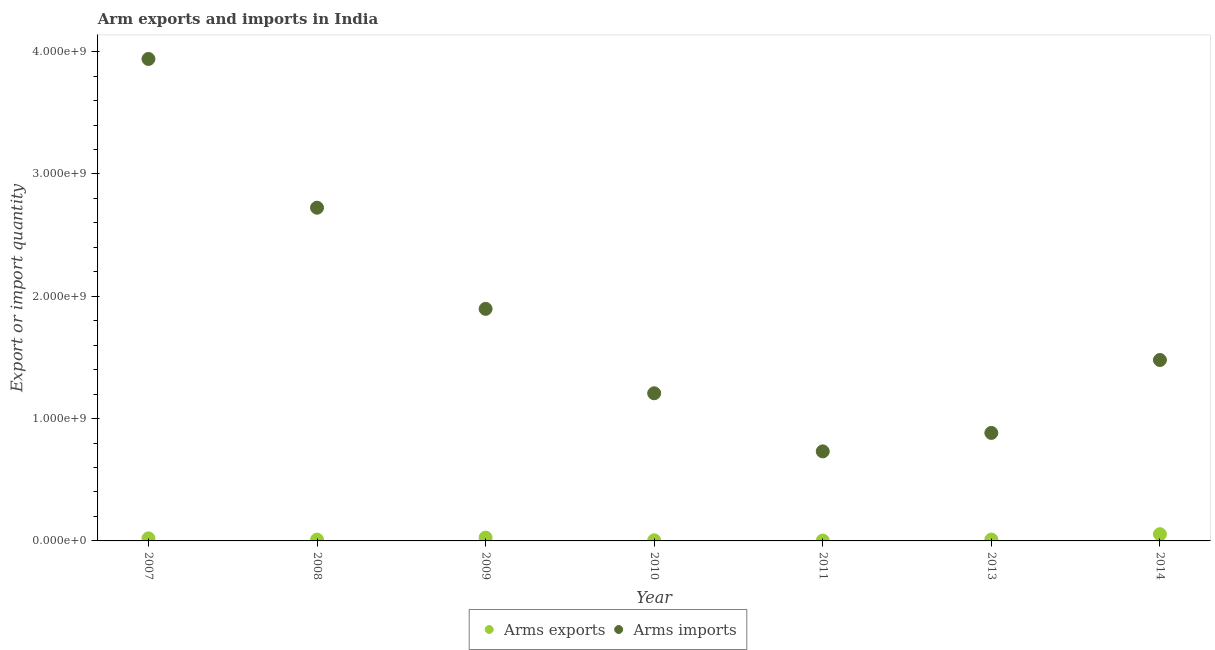What is the arms exports in 2007?
Offer a terse response. 2.10e+07. Across all years, what is the maximum arms exports?
Keep it short and to the point. 5.50e+07. Across all years, what is the minimum arms exports?
Your answer should be very brief. 3.00e+06. In which year was the arms exports maximum?
Make the answer very short. 2014. What is the total arms imports in the graph?
Make the answer very short. 1.29e+1. What is the difference between the arms imports in 2007 and that in 2013?
Offer a very short reply. 3.06e+09. What is the difference between the arms imports in 2011 and the arms exports in 2009?
Offer a terse response. 7.05e+08. What is the average arms imports per year?
Ensure brevity in your answer.  1.84e+09. In the year 2009, what is the difference between the arms exports and arms imports?
Your answer should be very brief. -1.87e+09. Is the arms imports in 2008 less than that in 2010?
Give a very brief answer. No. Is the difference between the arms exports in 2007 and 2010 greater than the difference between the arms imports in 2007 and 2010?
Offer a terse response. No. What is the difference between the highest and the second highest arms imports?
Provide a succinct answer. 1.22e+09. What is the difference between the highest and the lowest arms imports?
Provide a succinct answer. 3.21e+09. Is the sum of the arms exports in 2007 and 2010 greater than the maximum arms imports across all years?
Offer a terse response. No. Does the arms imports monotonically increase over the years?
Offer a terse response. No. How many dotlines are there?
Your response must be concise. 2. How many years are there in the graph?
Make the answer very short. 7. Are the values on the major ticks of Y-axis written in scientific E-notation?
Give a very brief answer. Yes. How many legend labels are there?
Your answer should be compact. 2. How are the legend labels stacked?
Ensure brevity in your answer.  Horizontal. What is the title of the graph?
Provide a short and direct response. Arm exports and imports in India. Does "Rural Population" appear as one of the legend labels in the graph?
Ensure brevity in your answer.  No. What is the label or title of the Y-axis?
Your answer should be very brief. Export or import quantity. What is the Export or import quantity in Arms exports in 2007?
Provide a succinct answer. 2.10e+07. What is the Export or import quantity in Arms imports in 2007?
Give a very brief answer. 3.94e+09. What is the Export or import quantity in Arms exports in 2008?
Your answer should be very brief. 1.10e+07. What is the Export or import quantity of Arms imports in 2008?
Offer a terse response. 2.72e+09. What is the Export or import quantity in Arms exports in 2009?
Your answer should be compact. 2.70e+07. What is the Export or import quantity in Arms imports in 2009?
Your response must be concise. 1.90e+09. What is the Export or import quantity in Arms exports in 2010?
Make the answer very short. 5.00e+06. What is the Export or import quantity of Arms imports in 2010?
Offer a very short reply. 1.21e+09. What is the Export or import quantity in Arms exports in 2011?
Ensure brevity in your answer.  3.00e+06. What is the Export or import quantity of Arms imports in 2011?
Keep it short and to the point. 7.32e+08. What is the Export or import quantity of Arms exports in 2013?
Your answer should be compact. 1.10e+07. What is the Export or import quantity of Arms imports in 2013?
Your response must be concise. 8.83e+08. What is the Export or import quantity in Arms exports in 2014?
Ensure brevity in your answer.  5.50e+07. What is the Export or import quantity of Arms imports in 2014?
Offer a very short reply. 1.48e+09. Across all years, what is the maximum Export or import quantity of Arms exports?
Make the answer very short. 5.50e+07. Across all years, what is the maximum Export or import quantity of Arms imports?
Provide a succinct answer. 3.94e+09. Across all years, what is the minimum Export or import quantity in Arms imports?
Your answer should be compact. 7.32e+08. What is the total Export or import quantity of Arms exports in the graph?
Make the answer very short. 1.33e+08. What is the total Export or import quantity in Arms imports in the graph?
Your response must be concise. 1.29e+1. What is the difference between the Export or import quantity in Arms imports in 2007 and that in 2008?
Provide a short and direct response. 1.22e+09. What is the difference between the Export or import quantity of Arms exports in 2007 and that in 2009?
Offer a terse response. -6.00e+06. What is the difference between the Export or import quantity in Arms imports in 2007 and that in 2009?
Your response must be concise. 2.04e+09. What is the difference between the Export or import quantity in Arms exports in 2007 and that in 2010?
Give a very brief answer. 1.60e+07. What is the difference between the Export or import quantity in Arms imports in 2007 and that in 2010?
Offer a very short reply. 2.73e+09. What is the difference between the Export or import quantity of Arms exports in 2007 and that in 2011?
Keep it short and to the point. 1.80e+07. What is the difference between the Export or import quantity in Arms imports in 2007 and that in 2011?
Your answer should be very brief. 3.21e+09. What is the difference between the Export or import quantity in Arms imports in 2007 and that in 2013?
Your answer should be compact. 3.06e+09. What is the difference between the Export or import quantity of Arms exports in 2007 and that in 2014?
Make the answer very short. -3.40e+07. What is the difference between the Export or import quantity in Arms imports in 2007 and that in 2014?
Provide a succinct answer. 2.46e+09. What is the difference between the Export or import quantity in Arms exports in 2008 and that in 2009?
Offer a terse response. -1.60e+07. What is the difference between the Export or import quantity in Arms imports in 2008 and that in 2009?
Make the answer very short. 8.27e+08. What is the difference between the Export or import quantity in Arms imports in 2008 and that in 2010?
Give a very brief answer. 1.52e+09. What is the difference between the Export or import quantity in Arms imports in 2008 and that in 2011?
Your response must be concise. 1.99e+09. What is the difference between the Export or import quantity in Arms imports in 2008 and that in 2013?
Offer a terse response. 1.84e+09. What is the difference between the Export or import quantity of Arms exports in 2008 and that in 2014?
Keep it short and to the point. -4.40e+07. What is the difference between the Export or import quantity of Arms imports in 2008 and that in 2014?
Your response must be concise. 1.24e+09. What is the difference between the Export or import quantity in Arms exports in 2009 and that in 2010?
Ensure brevity in your answer.  2.20e+07. What is the difference between the Export or import quantity in Arms imports in 2009 and that in 2010?
Your answer should be compact. 6.90e+08. What is the difference between the Export or import quantity of Arms exports in 2009 and that in 2011?
Provide a succinct answer. 2.40e+07. What is the difference between the Export or import quantity of Arms imports in 2009 and that in 2011?
Offer a terse response. 1.16e+09. What is the difference between the Export or import quantity of Arms exports in 2009 and that in 2013?
Provide a short and direct response. 1.60e+07. What is the difference between the Export or import quantity in Arms imports in 2009 and that in 2013?
Offer a very short reply. 1.01e+09. What is the difference between the Export or import quantity of Arms exports in 2009 and that in 2014?
Provide a succinct answer. -2.80e+07. What is the difference between the Export or import quantity in Arms imports in 2009 and that in 2014?
Offer a very short reply. 4.18e+08. What is the difference between the Export or import quantity of Arms exports in 2010 and that in 2011?
Your answer should be compact. 2.00e+06. What is the difference between the Export or import quantity in Arms imports in 2010 and that in 2011?
Give a very brief answer. 4.75e+08. What is the difference between the Export or import quantity in Arms exports in 2010 and that in 2013?
Provide a succinct answer. -6.00e+06. What is the difference between the Export or import quantity of Arms imports in 2010 and that in 2013?
Keep it short and to the point. 3.24e+08. What is the difference between the Export or import quantity of Arms exports in 2010 and that in 2014?
Your answer should be very brief. -5.00e+07. What is the difference between the Export or import quantity in Arms imports in 2010 and that in 2014?
Make the answer very short. -2.72e+08. What is the difference between the Export or import quantity of Arms exports in 2011 and that in 2013?
Your answer should be compact. -8.00e+06. What is the difference between the Export or import quantity in Arms imports in 2011 and that in 2013?
Keep it short and to the point. -1.51e+08. What is the difference between the Export or import quantity of Arms exports in 2011 and that in 2014?
Your response must be concise. -5.20e+07. What is the difference between the Export or import quantity of Arms imports in 2011 and that in 2014?
Offer a terse response. -7.47e+08. What is the difference between the Export or import quantity of Arms exports in 2013 and that in 2014?
Offer a very short reply. -4.40e+07. What is the difference between the Export or import quantity of Arms imports in 2013 and that in 2014?
Your answer should be very brief. -5.96e+08. What is the difference between the Export or import quantity in Arms exports in 2007 and the Export or import quantity in Arms imports in 2008?
Provide a short and direct response. -2.70e+09. What is the difference between the Export or import quantity of Arms exports in 2007 and the Export or import quantity of Arms imports in 2009?
Make the answer very short. -1.88e+09. What is the difference between the Export or import quantity in Arms exports in 2007 and the Export or import quantity in Arms imports in 2010?
Keep it short and to the point. -1.19e+09. What is the difference between the Export or import quantity in Arms exports in 2007 and the Export or import quantity in Arms imports in 2011?
Provide a succinct answer. -7.11e+08. What is the difference between the Export or import quantity in Arms exports in 2007 and the Export or import quantity in Arms imports in 2013?
Your answer should be very brief. -8.62e+08. What is the difference between the Export or import quantity in Arms exports in 2007 and the Export or import quantity in Arms imports in 2014?
Keep it short and to the point. -1.46e+09. What is the difference between the Export or import quantity in Arms exports in 2008 and the Export or import quantity in Arms imports in 2009?
Make the answer very short. -1.89e+09. What is the difference between the Export or import quantity in Arms exports in 2008 and the Export or import quantity in Arms imports in 2010?
Make the answer very short. -1.20e+09. What is the difference between the Export or import quantity in Arms exports in 2008 and the Export or import quantity in Arms imports in 2011?
Keep it short and to the point. -7.21e+08. What is the difference between the Export or import quantity in Arms exports in 2008 and the Export or import quantity in Arms imports in 2013?
Ensure brevity in your answer.  -8.72e+08. What is the difference between the Export or import quantity in Arms exports in 2008 and the Export or import quantity in Arms imports in 2014?
Provide a succinct answer. -1.47e+09. What is the difference between the Export or import quantity of Arms exports in 2009 and the Export or import quantity of Arms imports in 2010?
Ensure brevity in your answer.  -1.18e+09. What is the difference between the Export or import quantity of Arms exports in 2009 and the Export or import quantity of Arms imports in 2011?
Offer a terse response. -7.05e+08. What is the difference between the Export or import quantity of Arms exports in 2009 and the Export or import quantity of Arms imports in 2013?
Your response must be concise. -8.56e+08. What is the difference between the Export or import quantity in Arms exports in 2009 and the Export or import quantity in Arms imports in 2014?
Ensure brevity in your answer.  -1.45e+09. What is the difference between the Export or import quantity of Arms exports in 2010 and the Export or import quantity of Arms imports in 2011?
Your answer should be compact. -7.27e+08. What is the difference between the Export or import quantity of Arms exports in 2010 and the Export or import quantity of Arms imports in 2013?
Your answer should be compact. -8.78e+08. What is the difference between the Export or import quantity of Arms exports in 2010 and the Export or import quantity of Arms imports in 2014?
Provide a succinct answer. -1.47e+09. What is the difference between the Export or import quantity in Arms exports in 2011 and the Export or import quantity in Arms imports in 2013?
Ensure brevity in your answer.  -8.80e+08. What is the difference between the Export or import quantity in Arms exports in 2011 and the Export or import quantity in Arms imports in 2014?
Make the answer very short. -1.48e+09. What is the difference between the Export or import quantity of Arms exports in 2013 and the Export or import quantity of Arms imports in 2014?
Keep it short and to the point. -1.47e+09. What is the average Export or import quantity of Arms exports per year?
Your response must be concise. 1.90e+07. What is the average Export or import quantity in Arms imports per year?
Make the answer very short. 1.84e+09. In the year 2007, what is the difference between the Export or import quantity of Arms exports and Export or import quantity of Arms imports?
Your answer should be very brief. -3.92e+09. In the year 2008, what is the difference between the Export or import quantity in Arms exports and Export or import quantity in Arms imports?
Give a very brief answer. -2.71e+09. In the year 2009, what is the difference between the Export or import quantity in Arms exports and Export or import quantity in Arms imports?
Ensure brevity in your answer.  -1.87e+09. In the year 2010, what is the difference between the Export or import quantity of Arms exports and Export or import quantity of Arms imports?
Make the answer very short. -1.20e+09. In the year 2011, what is the difference between the Export or import quantity in Arms exports and Export or import quantity in Arms imports?
Offer a very short reply. -7.29e+08. In the year 2013, what is the difference between the Export or import quantity of Arms exports and Export or import quantity of Arms imports?
Keep it short and to the point. -8.72e+08. In the year 2014, what is the difference between the Export or import quantity of Arms exports and Export or import quantity of Arms imports?
Ensure brevity in your answer.  -1.42e+09. What is the ratio of the Export or import quantity of Arms exports in 2007 to that in 2008?
Offer a terse response. 1.91. What is the ratio of the Export or import quantity of Arms imports in 2007 to that in 2008?
Offer a terse response. 1.45. What is the ratio of the Export or import quantity of Arms exports in 2007 to that in 2009?
Your response must be concise. 0.78. What is the ratio of the Export or import quantity of Arms imports in 2007 to that in 2009?
Offer a very short reply. 2.08. What is the ratio of the Export or import quantity in Arms exports in 2007 to that in 2010?
Provide a succinct answer. 4.2. What is the ratio of the Export or import quantity in Arms imports in 2007 to that in 2010?
Offer a terse response. 3.26. What is the ratio of the Export or import quantity in Arms imports in 2007 to that in 2011?
Your answer should be very brief. 5.38. What is the ratio of the Export or import quantity of Arms exports in 2007 to that in 2013?
Give a very brief answer. 1.91. What is the ratio of the Export or import quantity of Arms imports in 2007 to that in 2013?
Give a very brief answer. 4.46. What is the ratio of the Export or import quantity of Arms exports in 2007 to that in 2014?
Keep it short and to the point. 0.38. What is the ratio of the Export or import quantity in Arms imports in 2007 to that in 2014?
Your answer should be compact. 2.66. What is the ratio of the Export or import quantity in Arms exports in 2008 to that in 2009?
Your response must be concise. 0.41. What is the ratio of the Export or import quantity in Arms imports in 2008 to that in 2009?
Provide a succinct answer. 1.44. What is the ratio of the Export or import quantity of Arms imports in 2008 to that in 2010?
Your answer should be very brief. 2.26. What is the ratio of the Export or import quantity in Arms exports in 2008 to that in 2011?
Offer a very short reply. 3.67. What is the ratio of the Export or import quantity of Arms imports in 2008 to that in 2011?
Offer a terse response. 3.72. What is the ratio of the Export or import quantity of Arms exports in 2008 to that in 2013?
Make the answer very short. 1. What is the ratio of the Export or import quantity in Arms imports in 2008 to that in 2013?
Your answer should be very brief. 3.08. What is the ratio of the Export or import quantity in Arms exports in 2008 to that in 2014?
Keep it short and to the point. 0.2. What is the ratio of the Export or import quantity of Arms imports in 2008 to that in 2014?
Your answer should be very brief. 1.84. What is the ratio of the Export or import quantity of Arms imports in 2009 to that in 2010?
Offer a terse response. 1.57. What is the ratio of the Export or import quantity in Arms imports in 2009 to that in 2011?
Make the answer very short. 2.59. What is the ratio of the Export or import quantity of Arms exports in 2009 to that in 2013?
Provide a short and direct response. 2.45. What is the ratio of the Export or import quantity of Arms imports in 2009 to that in 2013?
Your response must be concise. 2.15. What is the ratio of the Export or import quantity of Arms exports in 2009 to that in 2014?
Your answer should be compact. 0.49. What is the ratio of the Export or import quantity in Arms imports in 2009 to that in 2014?
Provide a short and direct response. 1.28. What is the ratio of the Export or import quantity in Arms imports in 2010 to that in 2011?
Give a very brief answer. 1.65. What is the ratio of the Export or import quantity of Arms exports in 2010 to that in 2013?
Give a very brief answer. 0.45. What is the ratio of the Export or import quantity in Arms imports in 2010 to that in 2013?
Ensure brevity in your answer.  1.37. What is the ratio of the Export or import quantity of Arms exports in 2010 to that in 2014?
Make the answer very short. 0.09. What is the ratio of the Export or import quantity of Arms imports in 2010 to that in 2014?
Provide a short and direct response. 0.82. What is the ratio of the Export or import quantity in Arms exports in 2011 to that in 2013?
Provide a succinct answer. 0.27. What is the ratio of the Export or import quantity in Arms imports in 2011 to that in 2013?
Ensure brevity in your answer.  0.83. What is the ratio of the Export or import quantity in Arms exports in 2011 to that in 2014?
Your response must be concise. 0.05. What is the ratio of the Export or import quantity in Arms imports in 2011 to that in 2014?
Make the answer very short. 0.49. What is the ratio of the Export or import quantity in Arms exports in 2013 to that in 2014?
Ensure brevity in your answer.  0.2. What is the ratio of the Export or import quantity of Arms imports in 2013 to that in 2014?
Give a very brief answer. 0.6. What is the difference between the highest and the second highest Export or import quantity of Arms exports?
Offer a very short reply. 2.80e+07. What is the difference between the highest and the second highest Export or import quantity in Arms imports?
Offer a very short reply. 1.22e+09. What is the difference between the highest and the lowest Export or import quantity in Arms exports?
Your response must be concise. 5.20e+07. What is the difference between the highest and the lowest Export or import quantity in Arms imports?
Keep it short and to the point. 3.21e+09. 